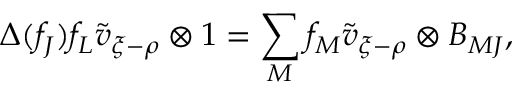<formula> <loc_0><loc_0><loc_500><loc_500>\Delta ( f _ { J } ) f _ { L } \tilde { v } _ { \xi - \rho } \otimes 1 = \sum _ { M } f _ { M } \tilde { v } _ { \xi - \rho } \otimes B _ { M J } ,</formula> 